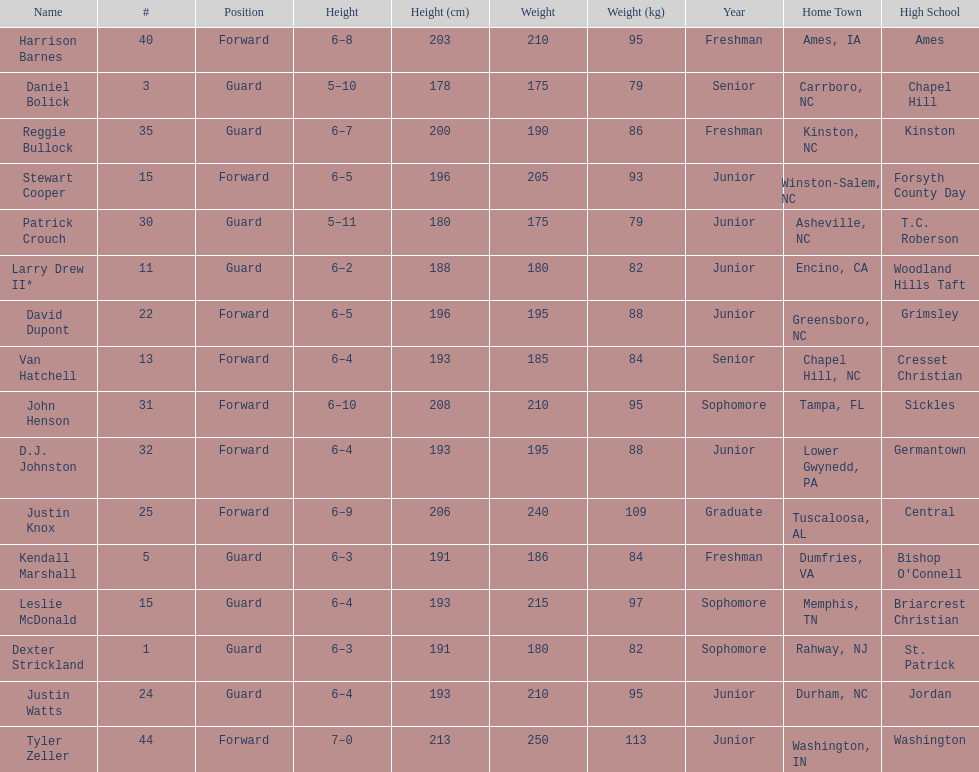What is the number of players with a weight over 200? 7. 